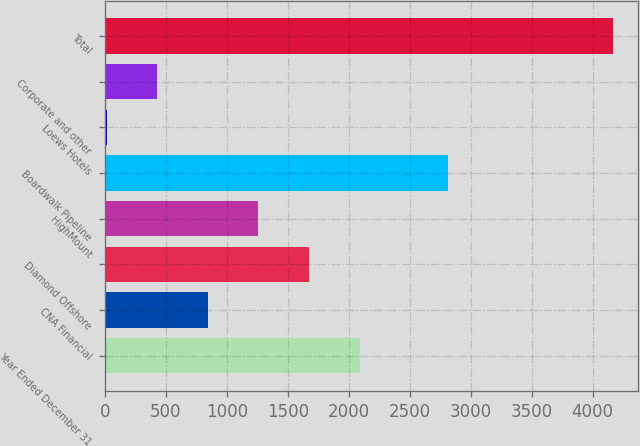Convert chart to OTSL. <chart><loc_0><loc_0><loc_500><loc_500><bar_chart><fcel>Year Ended December 31<fcel>CNA Financial<fcel>Diamond Offshore<fcel>HighMount<fcel>Boardwalk Pipeline<fcel>Loews Hotels<fcel>Corporate and other<fcel>Total<nl><fcel>2089<fcel>844.6<fcel>1674.2<fcel>1259.4<fcel>2812<fcel>15<fcel>429.8<fcel>4163<nl></chart> 